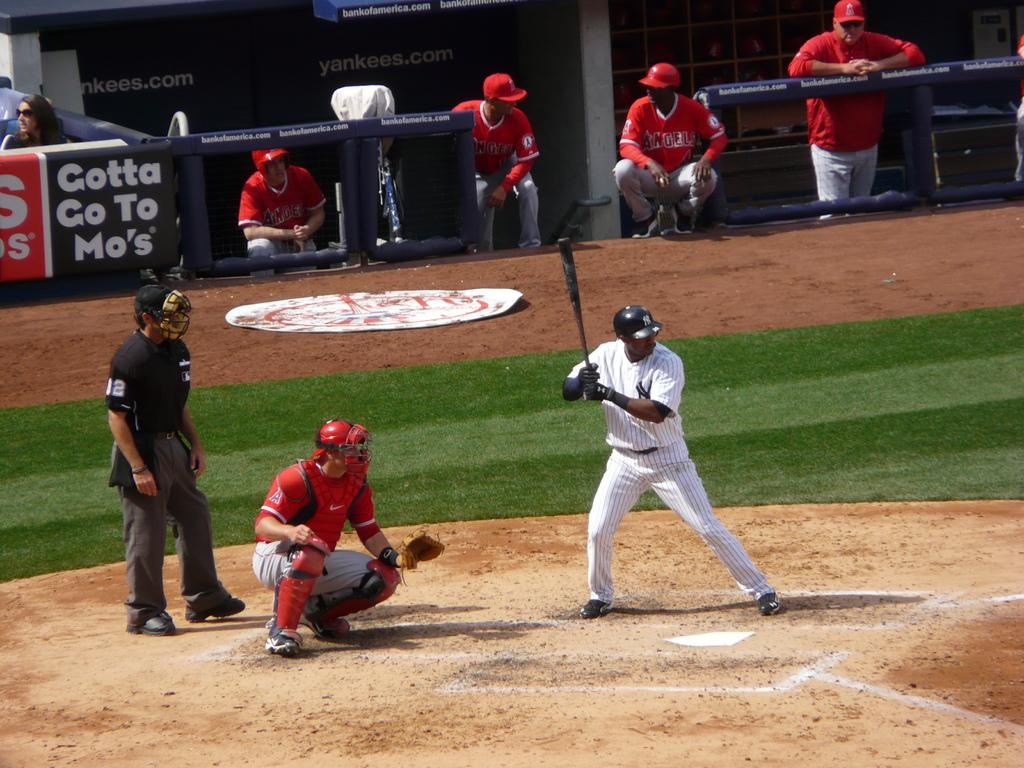<image>
Give a short and clear explanation of the subsequent image. A New York Yankees player is about to bat 